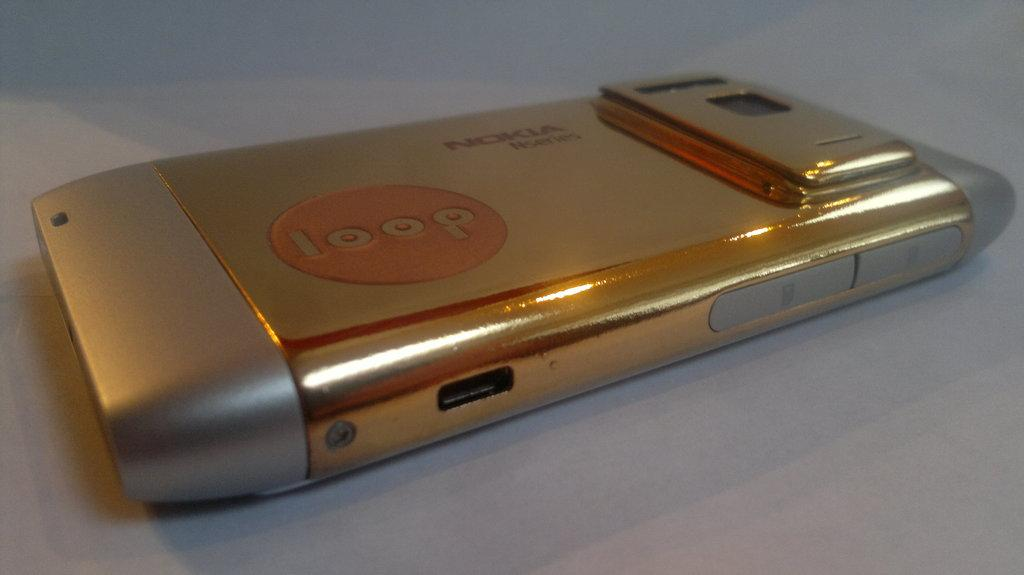<image>
Provide a brief description of the given image. Phone by Nokia gold in color and loop written on it. 